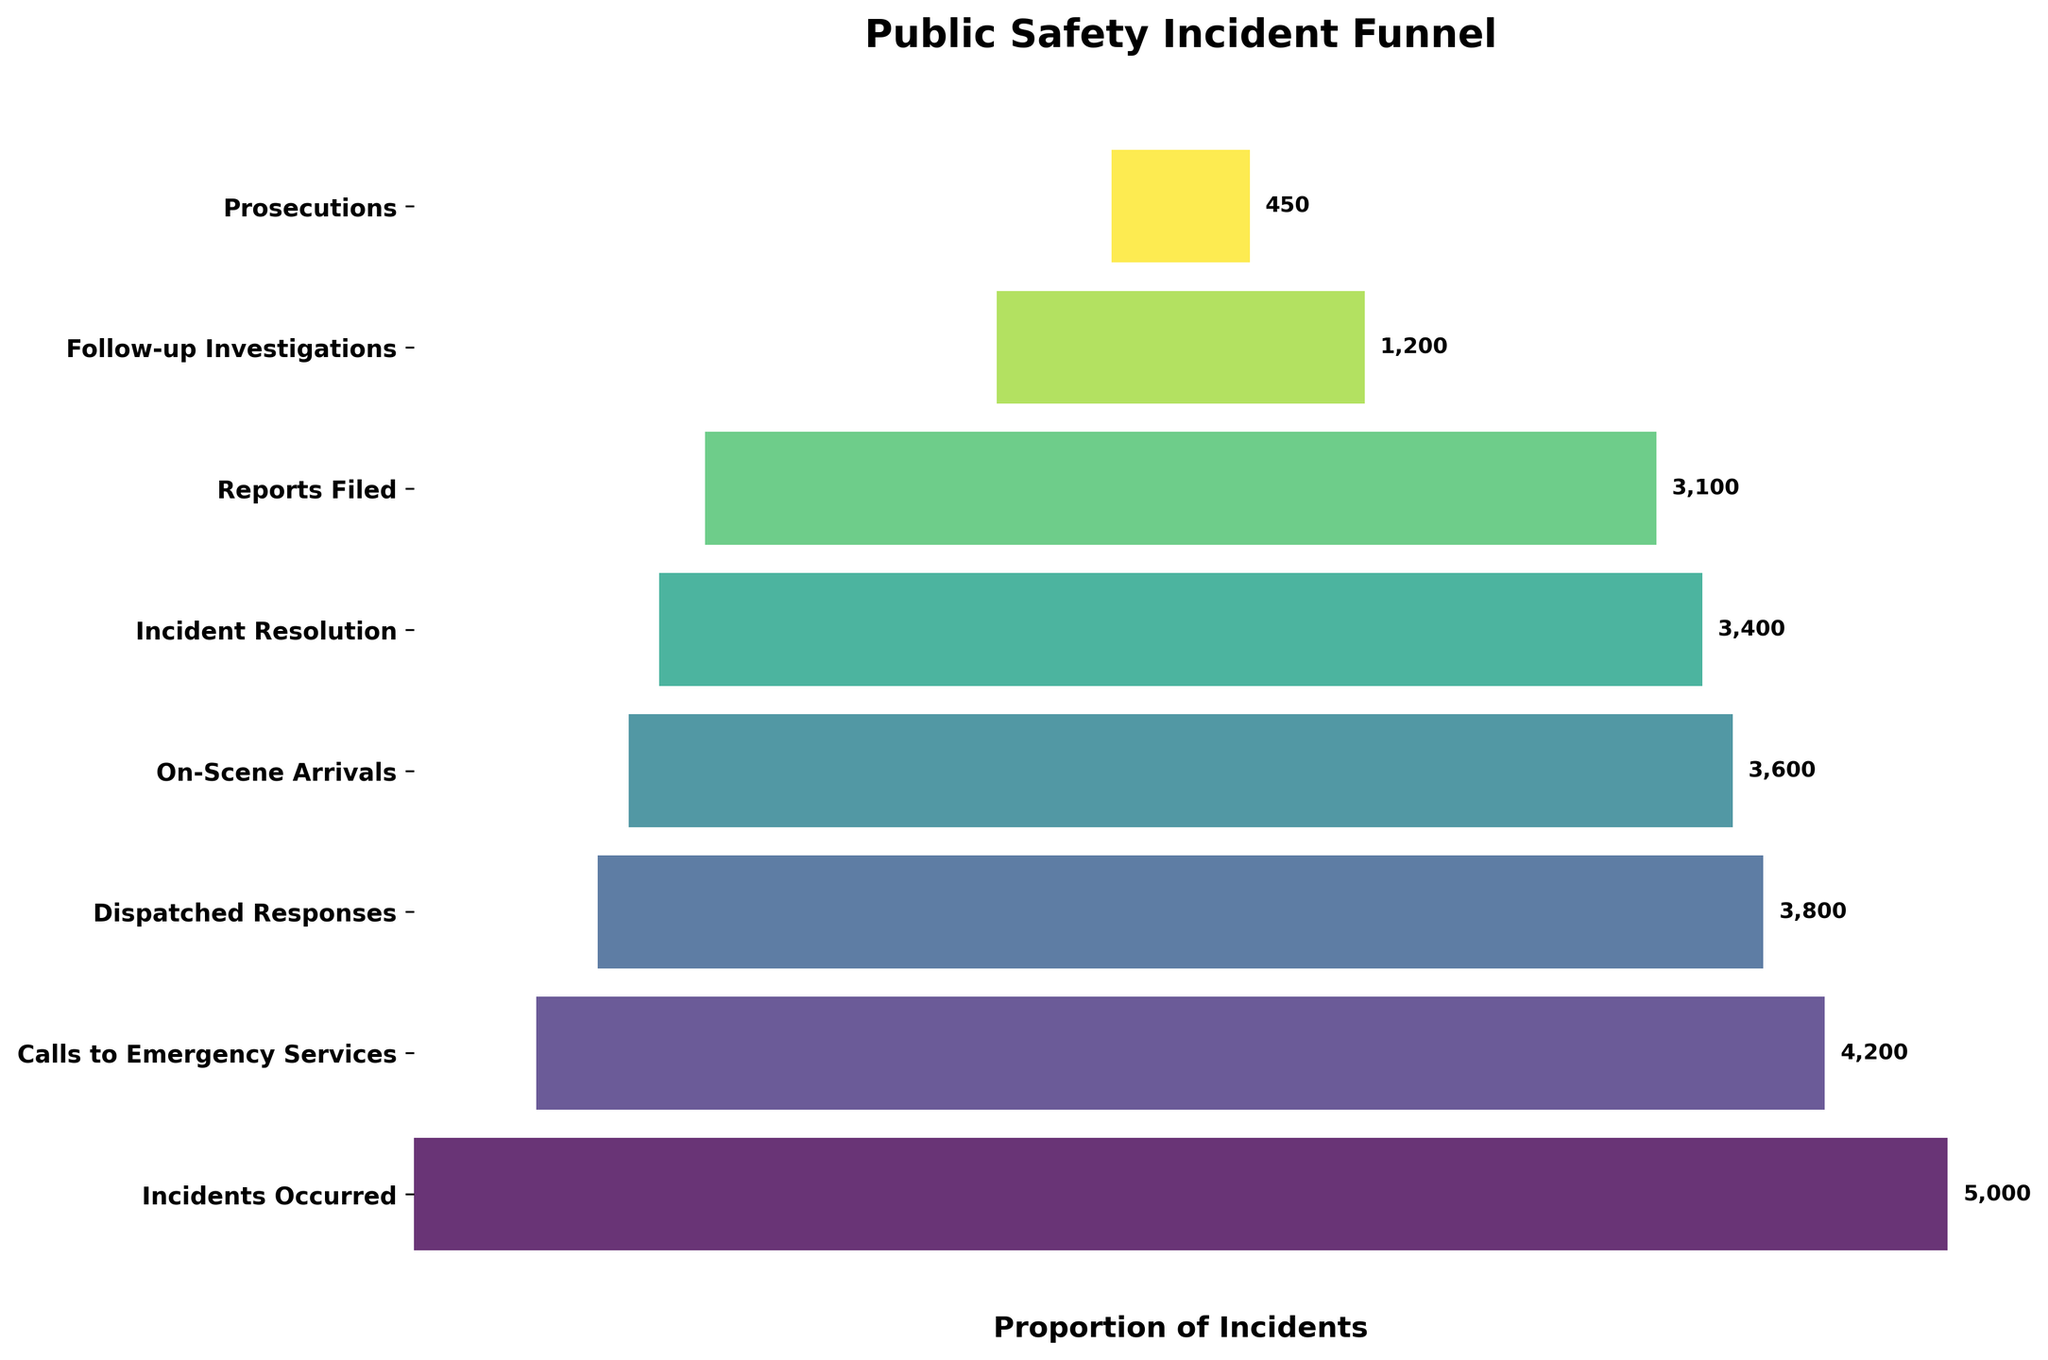What's the title of the figure? The title of the figure is shown at the top in bold, which states its purpose and context.
Answer: Public Safety Incident Funnel How many incidents were reported to emergency services? The number is shown in the second stage of the funnel chart.
Answer: 4200 What is the difference between the number of incidents occurred and incidents resolved? The number of incidents at each stage is listed. Subtract the number of incidents resolved from the number of incidents occurred. 5000 - 3400 = 1600
Answer: 1600 Which stage has the lowest number of incidents? The stage with the smallest bar and the lowest number associated with it is identified as the stage with the lowest number of incidents.
Answer: Prosecutions What fraction of the initial incidents resulted in follow-up investigations? Divide the number of follow-up investigations by the number of incidents occurred and express the result as a fraction. 1200 / 5000 = 0.24
Answer: 0.24 How many more dispatched responses were there than prosecutions? Find the difference between the numbers for dispatched responses and prosecutions. 3800 - 450 = 3350
Answer: 3350 What proportion of incidents required on-scene arrivals out of the total incidents occurred? Divide the number of on-scene arrivals by the total number of incidents occurred. 3600 / 5000 = 0.72
Answer: 0.72 Compare the number of reports filed to the number of incident resolutions. Which is higher? Compare the numbers given for reports filed and incident resolutions.
Answer: Incident resolutions Of the total incidents that occurred, what percentage proceeded to prosecution? Divide the number of prosecutions by the total number of incidents occurred and multiply by 100 to convert to a percentage. (450 / 5000) * 100 = 9%
Answer: 9% What's the decrease in incidents from dispatched responses to on-scene arrivals? Subtract the number of on-scene arrivals from the number of dispatched responses. 3800 - 3600 = 200
Answer: 200 